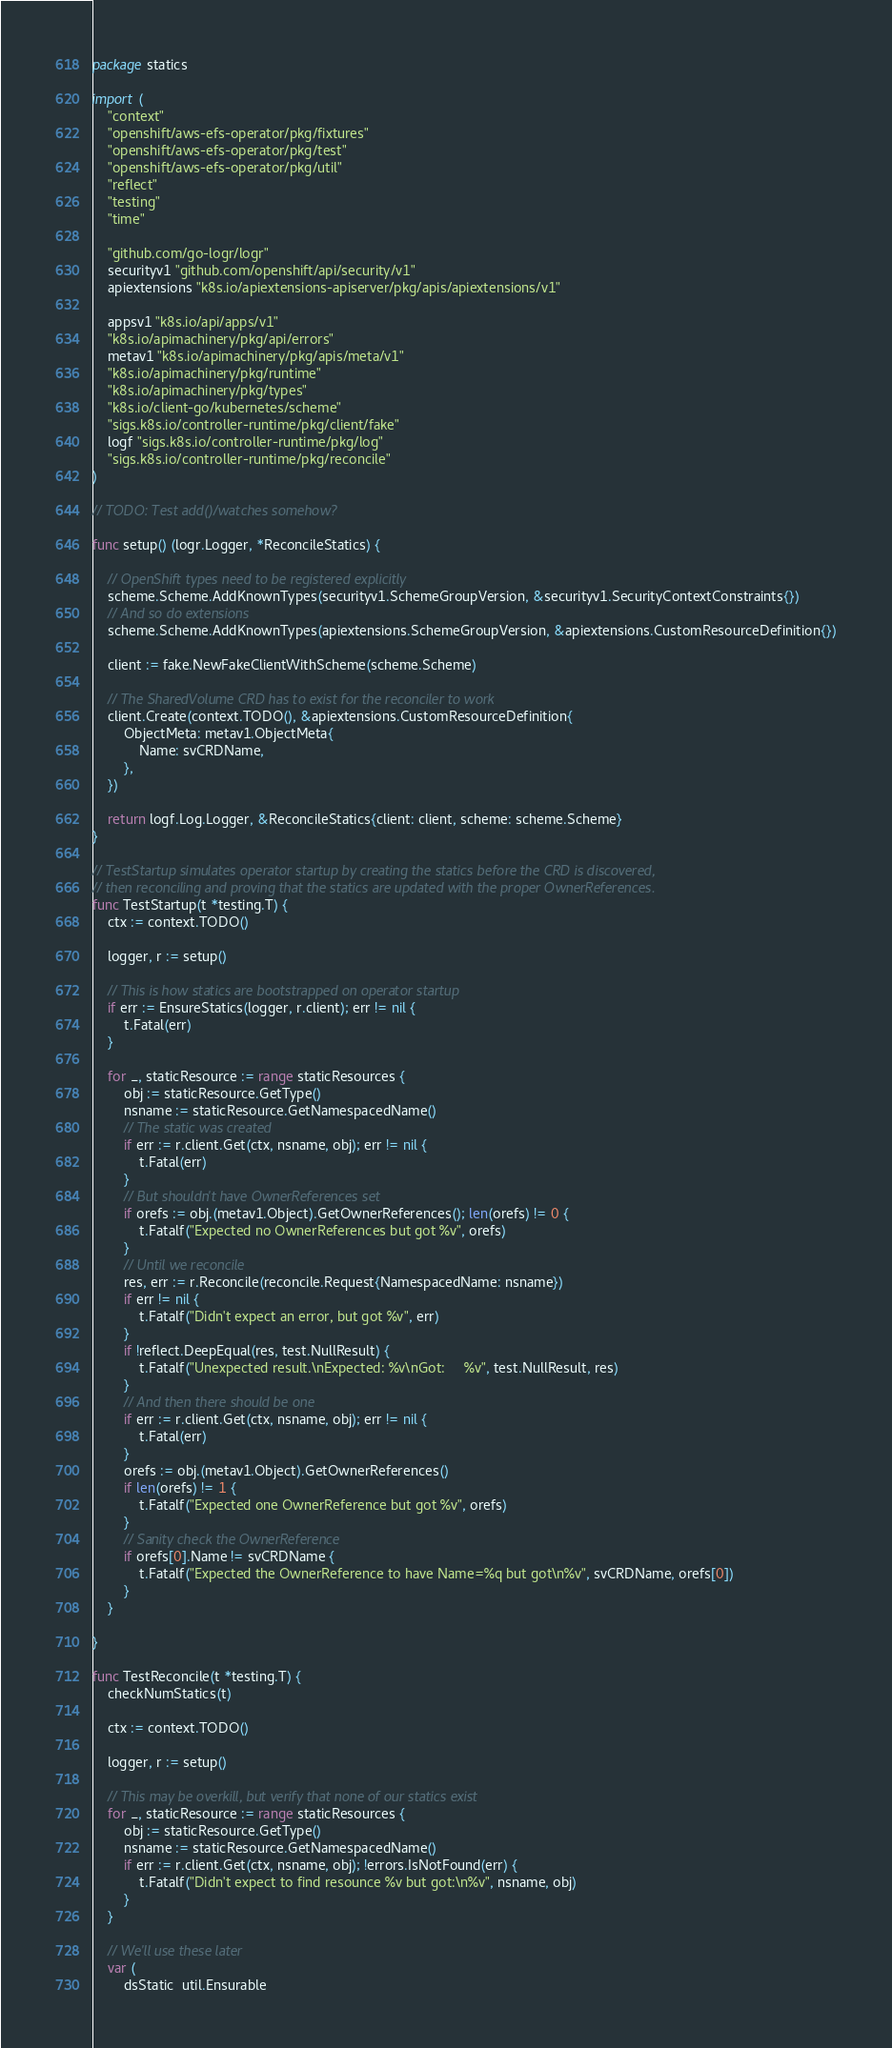Convert code to text. <code><loc_0><loc_0><loc_500><loc_500><_Go_>package statics

import (
	"context"
	"openshift/aws-efs-operator/pkg/fixtures"
	"openshift/aws-efs-operator/pkg/test"
	"openshift/aws-efs-operator/pkg/util"
	"reflect"
	"testing"
	"time"

	"github.com/go-logr/logr"
	securityv1 "github.com/openshift/api/security/v1"
	apiextensions "k8s.io/apiextensions-apiserver/pkg/apis/apiextensions/v1"

	appsv1 "k8s.io/api/apps/v1"
	"k8s.io/apimachinery/pkg/api/errors"
	metav1 "k8s.io/apimachinery/pkg/apis/meta/v1"
	"k8s.io/apimachinery/pkg/runtime"
	"k8s.io/apimachinery/pkg/types"
	"k8s.io/client-go/kubernetes/scheme"
	"sigs.k8s.io/controller-runtime/pkg/client/fake"
	logf "sigs.k8s.io/controller-runtime/pkg/log"
	"sigs.k8s.io/controller-runtime/pkg/reconcile"
)

// TODO: Test add()/watches somehow?

func setup() (logr.Logger, *ReconcileStatics) {

	// OpenShift types need to be registered explicitly
	scheme.Scheme.AddKnownTypes(securityv1.SchemeGroupVersion, &securityv1.SecurityContextConstraints{})
	// And so do extensions
	scheme.Scheme.AddKnownTypes(apiextensions.SchemeGroupVersion, &apiextensions.CustomResourceDefinition{})

	client := fake.NewFakeClientWithScheme(scheme.Scheme)

	// The SharedVolume CRD has to exist for the reconciler to work
	client.Create(context.TODO(), &apiextensions.CustomResourceDefinition{
		ObjectMeta: metav1.ObjectMeta{
			Name: svCRDName,
		},
	})

	return logf.Log.Logger, &ReconcileStatics{client: client, scheme: scheme.Scheme}
}

// TestStartup simulates operator startup by creating the statics before the CRD is discovered,
// then reconciling and proving that the statics are updated with the proper OwnerReferences.
func TestStartup(t *testing.T) {
	ctx := context.TODO()

	logger, r := setup()

	// This is how statics are bootstrapped on operator startup
	if err := EnsureStatics(logger, r.client); err != nil {
		t.Fatal(err)
	}

	for _, staticResource := range staticResources {
		obj := staticResource.GetType()
		nsname := staticResource.GetNamespacedName()
		// The static was created
		if err := r.client.Get(ctx, nsname, obj); err != nil {
			t.Fatal(err)
		}
		// But shouldn't have OwnerReferences set
		if orefs := obj.(metav1.Object).GetOwnerReferences(); len(orefs) != 0 {
			t.Fatalf("Expected no OwnerReferences but got %v", orefs)
		}
		// Until we reconcile
		res, err := r.Reconcile(reconcile.Request{NamespacedName: nsname})
		if err != nil {
			t.Fatalf("Didn't expect an error, but got %v", err)
		}
		if !reflect.DeepEqual(res, test.NullResult) {
			t.Fatalf("Unexpected result.\nExpected: %v\nGot:     %v", test.NullResult, res)
		}
		// And then there should be one
		if err := r.client.Get(ctx, nsname, obj); err != nil {
			t.Fatal(err)
		}
		orefs := obj.(metav1.Object).GetOwnerReferences()
		if len(orefs) != 1 {
			t.Fatalf("Expected one OwnerReference but got %v", orefs)
		}
		// Sanity check the OwnerReference
		if orefs[0].Name != svCRDName {
			t.Fatalf("Expected the OwnerReference to have Name=%q but got\n%v", svCRDName, orefs[0])
		}
	}

}

func TestReconcile(t *testing.T) {
	checkNumStatics(t)

	ctx := context.TODO()

	logger, r := setup()

	// This may be overkill, but verify that none of our statics exist
	for _, staticResource := range staticResources {
		obj := staticResource.GetType()
		nsname := staticResource.GetNamespacedName()
		if err := r.client.Get(ctx, nsname, obj); !errors.IsNotFound(err) {
			t.Fatalf("Didn't expect to find resounce %v but got:\n%v", nsname, obj)
		}
	}

	// We'll use these later
	var (
		dsStatic  util.Ensurable</code> 